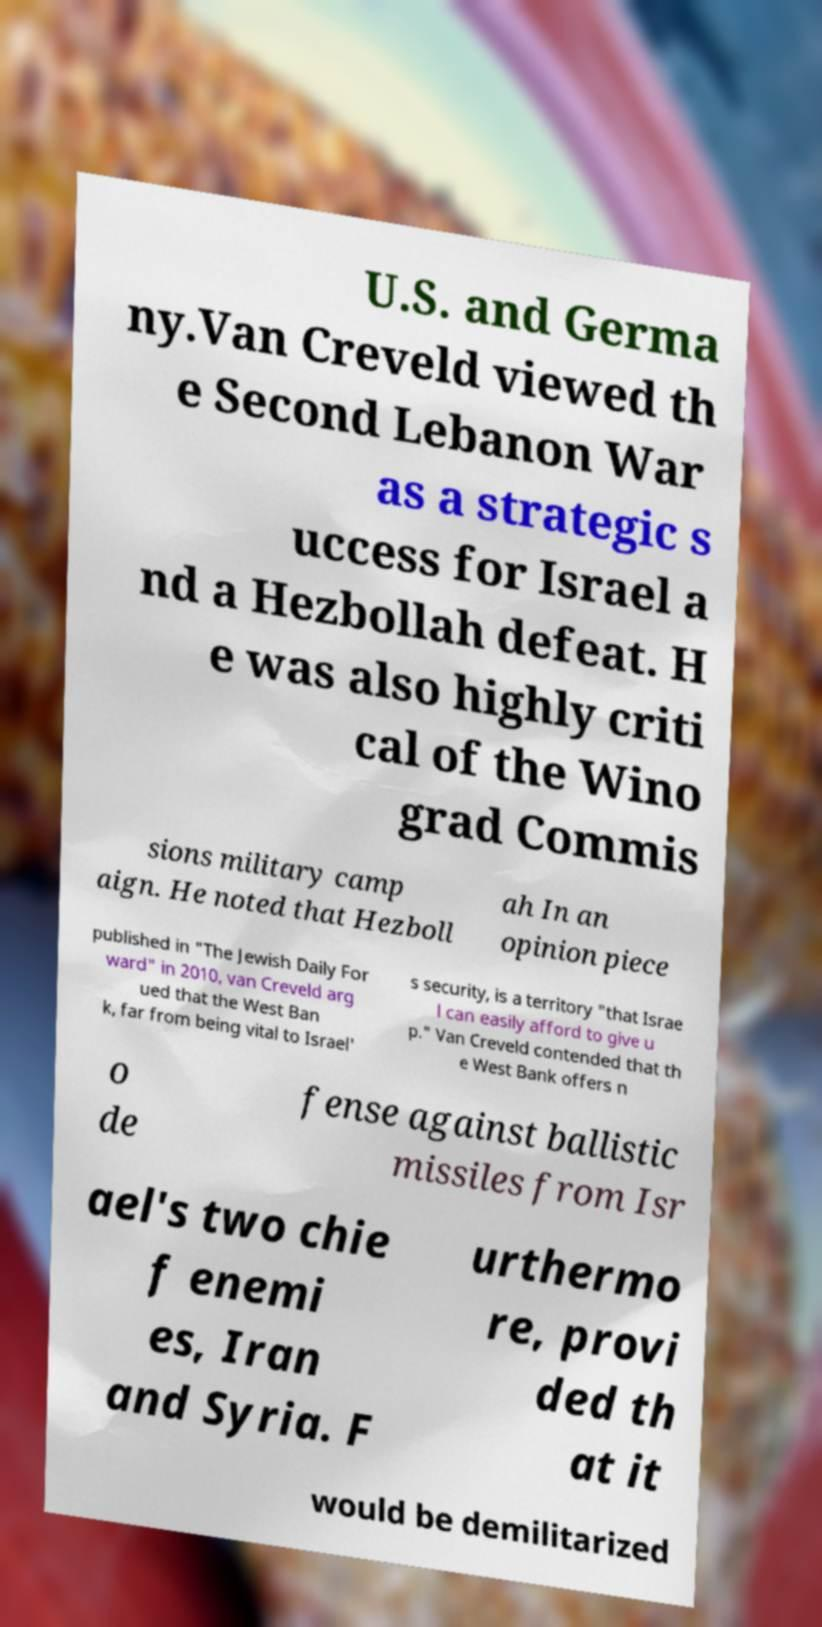Can you read and provide the text displayed in the image?This photo seems to have some interesting text. Can you extract and type it out for me? U.S. and Germa ny.Van Creveld viewed th e Second Lebanon War as a strategic s uccess for Israel a nd a Hezbollah defeat. H e was also highly criti cal of the Wino grad Commis sions military camp aign. He noted that Hezboll ah In an opinion piece published in "The Jewish Daily For ward" in 2010, van Creveld arg ued that the West Ban k, far from being vital to Israel' s security, is a territory "that Israe l can easily afford to give u p." Van Creveld contended that th e West Bank offers n o de fense against ballistic missiles from Isr ael's two chie f enemi es, Iran and Syria. F urthermo re, provi ded th at it would be demilitarized 